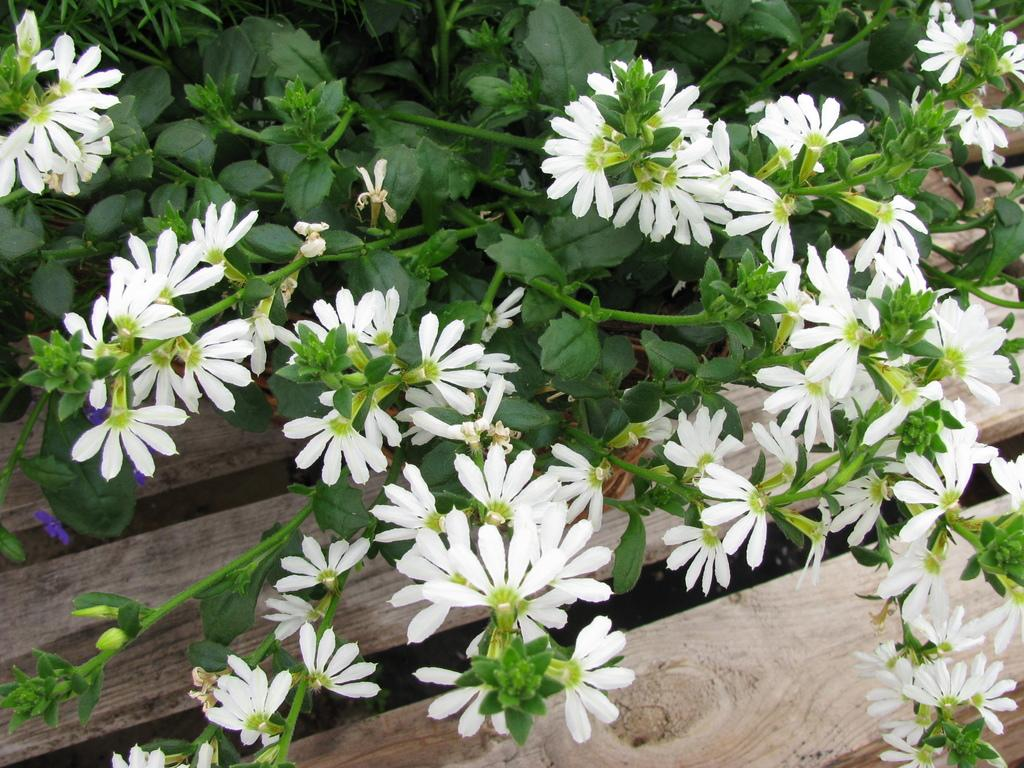What type of flowers are on the plants in the picture? The plants in the picture have white flowers. Can you describe the wooden object in the picture? Unfortunately, there is not enough information provided to describe the wooden object in the picture. How many eyes can be seen on the goat in the picture? There is no goat present in the picture, so it is not possible to determine how many eyes are visible. 